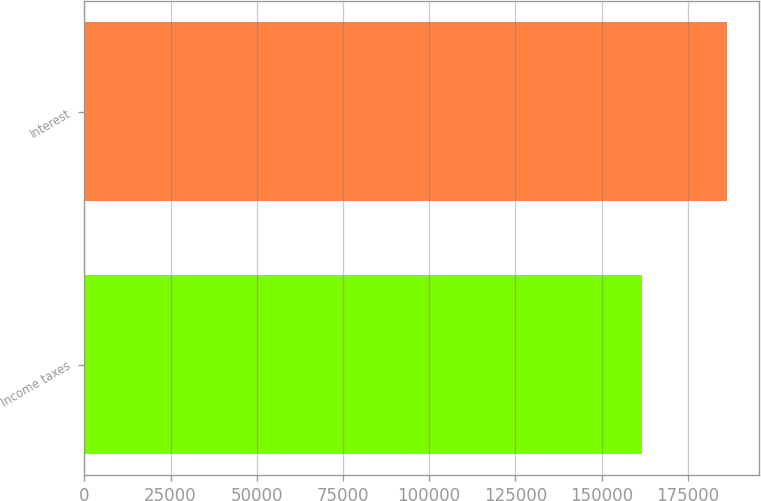<chart> <loc_0><loc_0><loc_500><loc_500><bar_chart><fcel>Income taxes<fcel>Interest<nl><fcel>161671<fcel>186280<nl></chart> 